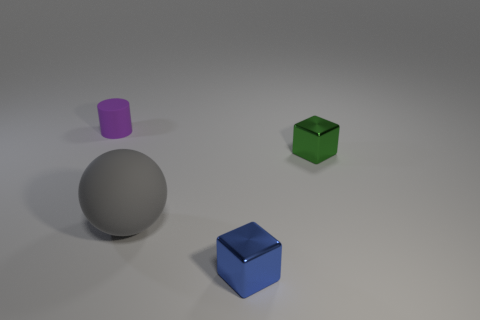There is a tiny shiny thing on the right side of the tiny blue cube; is its shape the same as the large gray object?
Provide a short and direct response. No. Are there fewer small cubes in front of the tiny green cube than shiny blocks left of the small blue thing?
Your answer should be compact. No. What is the material of the blue thing left of the small green object?
Offer a very short reply. Metal. Are there any yellow rubber cubes that have the same size as the green object?
Your response must be concise. No. Is the shape of the purple rubber object the same as the object in front of the gray rubber ball?
Make the answer very short. No. Is the size of the rubber thing that is left of the big matte object the same as the block in front of the tiny green block?
Your answer should be compact. Yes. What number of other things are the same shape as the gray object?
Your answer should be compact. 0. What is the small object that is to the right of the shiny block on the left side of the small green metallic object made of?
Offer a very short reply. Metal. How many matte objects are blue things or yellow cylinders?
Offer a terse response. 0. Is there anything else that is made of the same material as the small purple cylinder?
Give a very brief answer. Yes. 